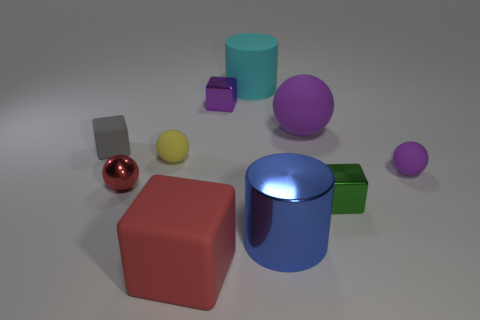Subtract all tiny blocks. How many blocks are left? 1 Subtract all brown blocks. How many purple spheres are left? 2 Subtract all cylinders. How many objects are left? 8 Subtract all purple cubes. How many cubes are left? 3 Add 3 small gray matte cubes. How many small gray matte cubes exist? 4 Subtract 0 brown blocks. How many objects are left? 10 Subtract all yellow cylinders. Subtract all red spheres. How many cylinders are left? 2 Subtract all small red matte blocks. Subtract all tiny matte things. How many objects are left? 7 Add 4 matte balls. How many matte balls are left? 7 